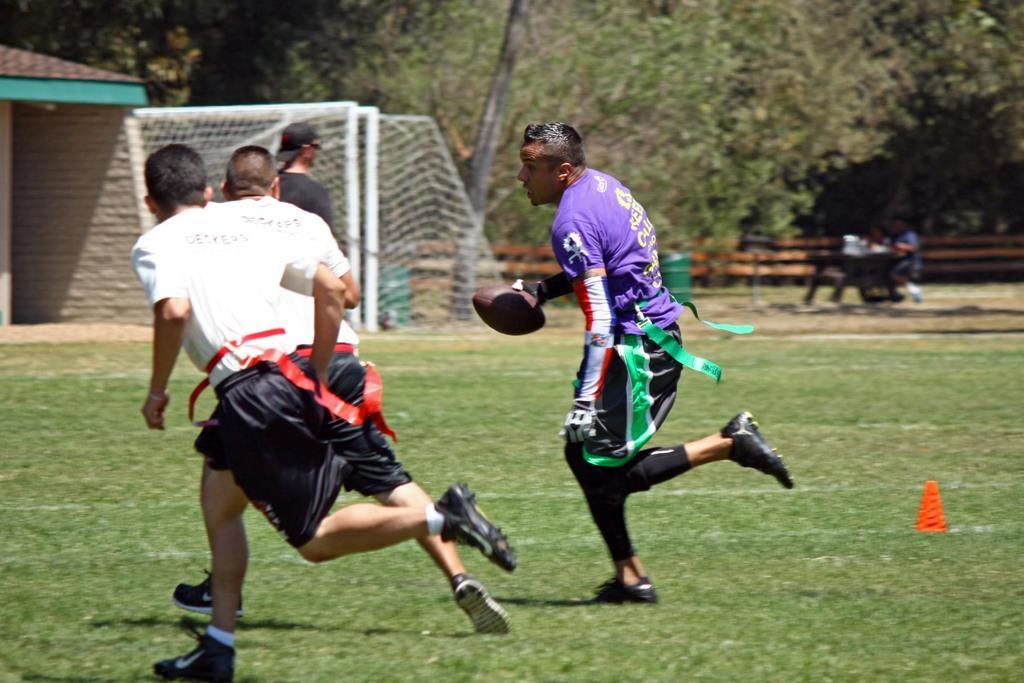In one or two sentences, can you explain what this image depicts? there are so many players running on a ground one of them holding a ball in his hand behind them there are so many trees and a net. 